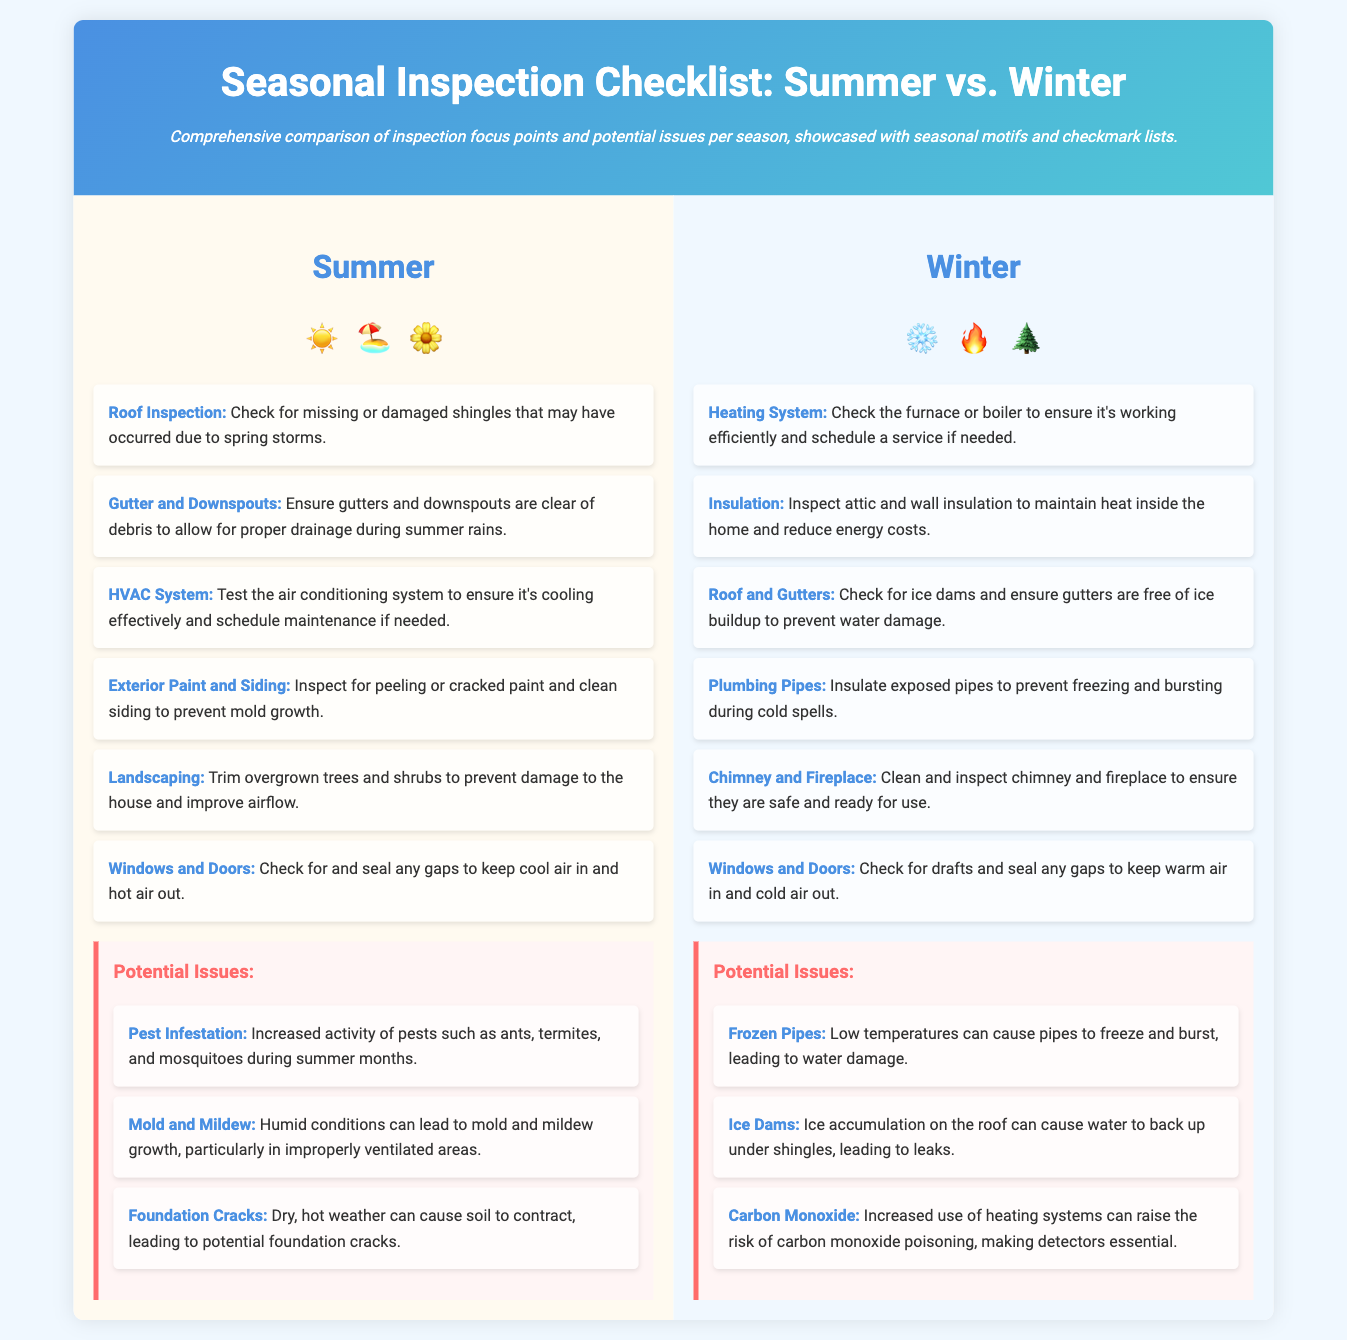What seasonal motifs are used in the summer section? The summer section features motifs like the sun, beach, and flowers.
Answer: ☀️🏖️🌼 What should you inspect regarding the HVAC system in summer? You should test the air conditioning system to ensure it's cooling effectively.
Answer: Cooling effectiveness What is one potential issue during summer? One potential issue during summer is increased pest infestation.
Answer: Pest infestation What item is focused on for insulation in winter? The focus is on inspecting attic and wall insulation for efficiency.
Answer: Attic and wall insulation What should be checked for ice buildup in winter? You should check the roof and gutters for ice dams.
Answer: Ice dams How many key inspection points are listed for winter? There are six key inspection points listed for winter.
Answer: Six What action is recommended for landscaping in summer? It is recommended to trim overgrown trees and shrubs.
Answer: Trim trees and shrubs What is the significance of checking windows and doors? It helps to keep cool air in and hot air out during summer, and warm air in during winter.
Answer: Energy efficiency What potential issue involves heating systems in winter? A potential issue is the risk of carbon monoxide poisoning.
Answer: Carbon monoxide 